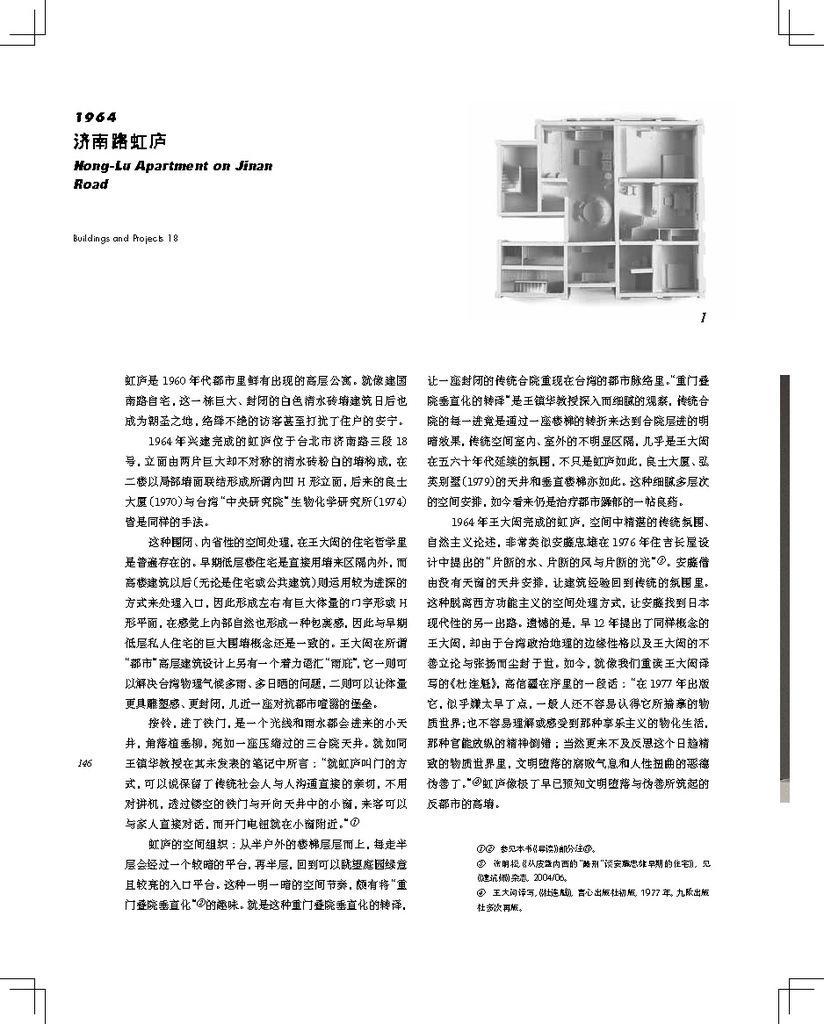What is the year listed on the top of this page?
Give a very brief answer. 1964. 